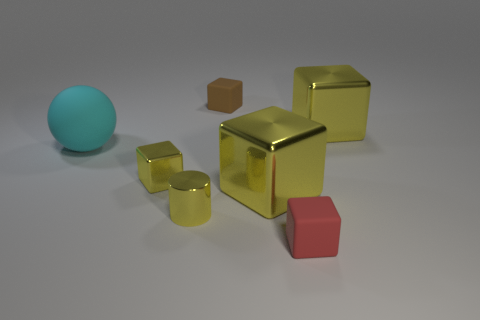What shape is the small object that is the same color as the metallic cylinder? The small object sharing the same color as the metallic cylinder is a cube. It exhibits a distinct geometric shape with six equal square faces, a testament to its perfect cubic structure. 